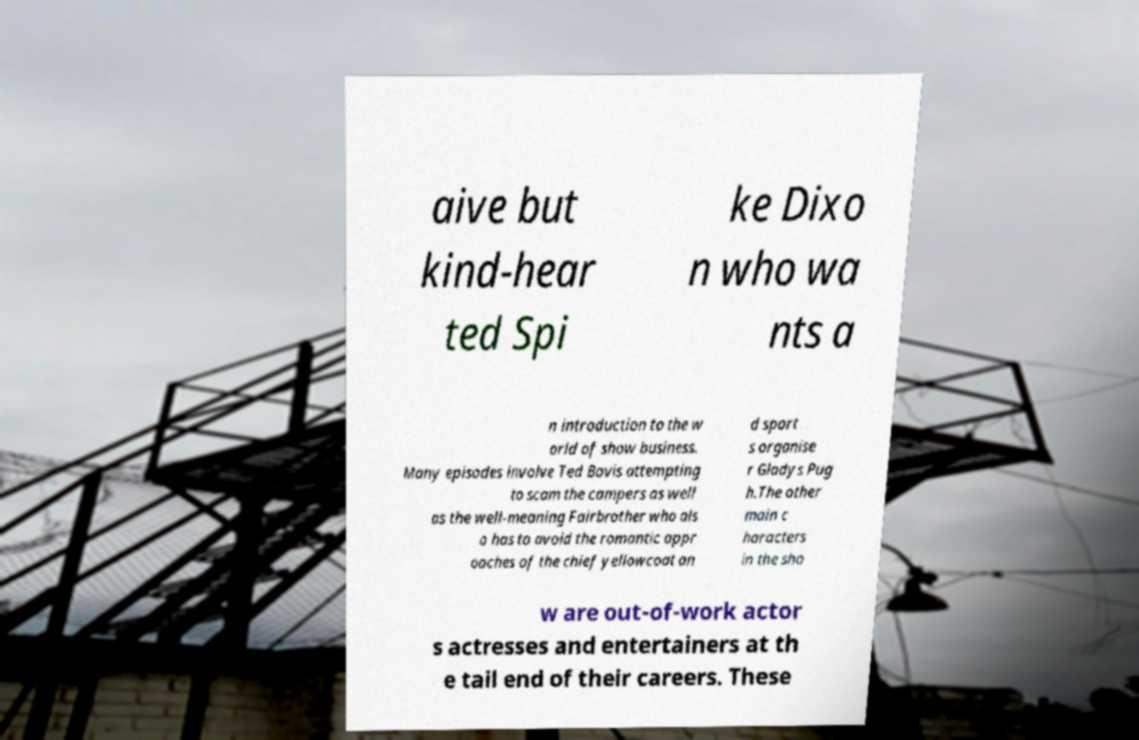Could you assist in decoding the text presented in this image and type it out clearly? aive but kind-hear ted Spi ke Dixo n who wa nts a n introduction to the w orld of show business. Many episodes involve Ted Bovis attempting to scam the campers as well as the well-meaning Fairbrother who als o has to avoid the romantic appr oaches of the chief yellowcoat an d sport s organise r Gladys Pug h.The other main c haracters in the sho w are out-of-work actor s actresses and entertainers at th e tail end of their careers. These 